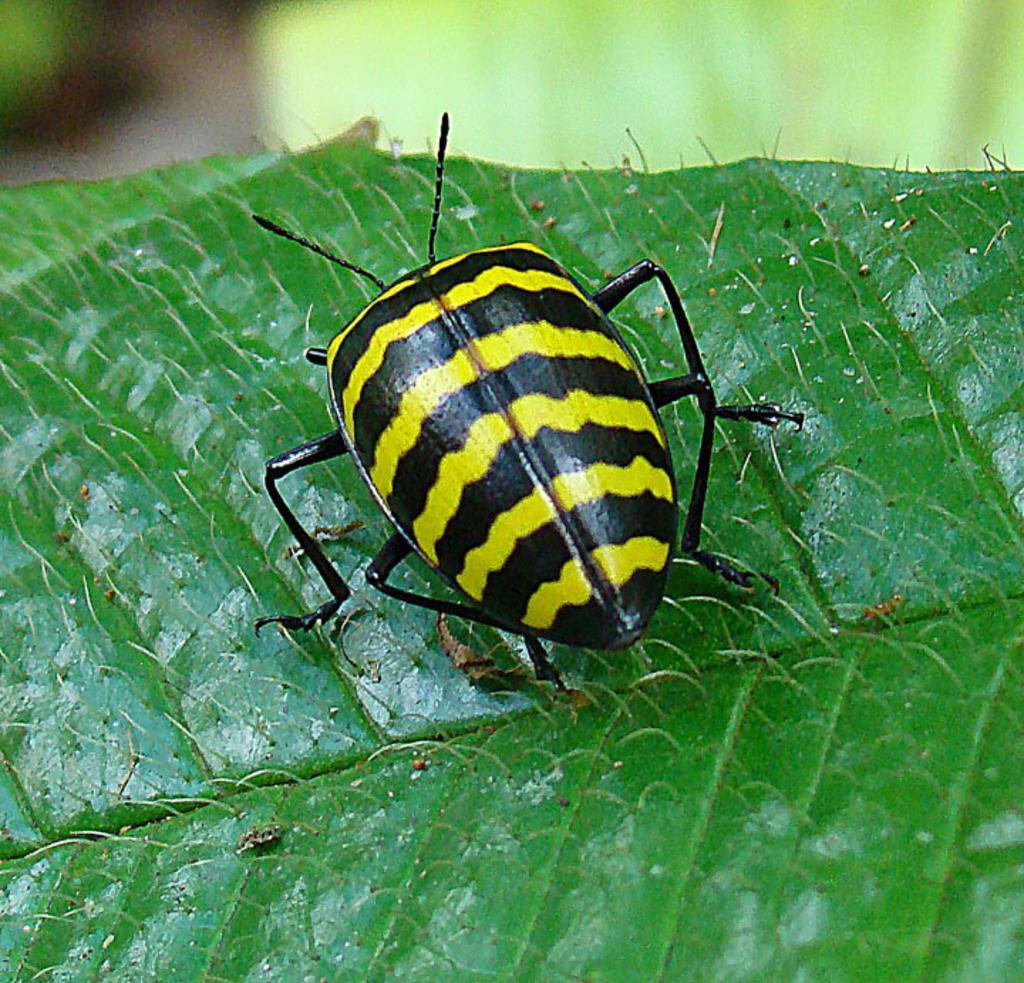Could you give a brief overview of what you see in this image? In this image I can see a green colour leaf and on it I can see a black and yellow colour insect. I can also see this image is little bit blurry in the background. 